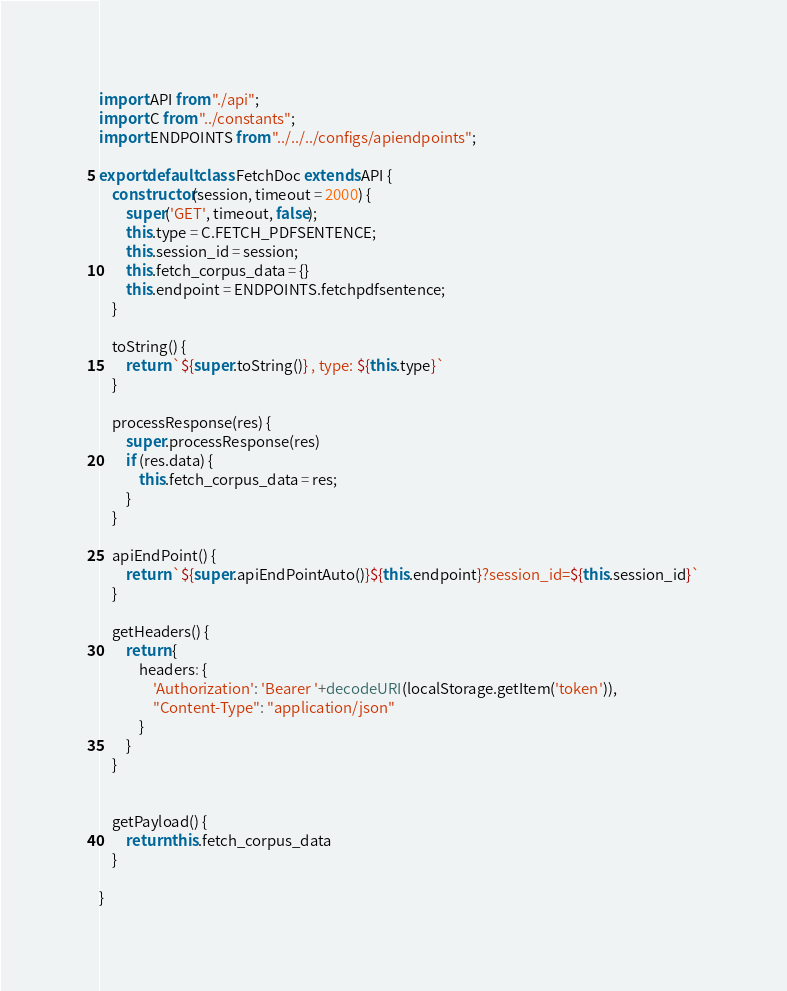<code> <loc_0><loc_0><loc_500><loc_500><_JavaScript_>import API from "./api";
import C from "../constants";
import ENDPOINTS from "../../../configs/apiendpoints";

export default class FetchDoc extends API {
    constructor(session, timeout = 2000) {
        super('GET', timeout, false);
        this.type = C.FETCH_PDFSENTENCE;
        this.session_id = session;
        this.fetch_corpus_data = {}
        this.endpoint = ENDPOINTS.fetchpdfsentence;
    }

    toString() {
        return `${super.toString()} , type: ${this.type}`
    }

    processResponse(res) {
        super.processResponse(res)
        if (res.data) {
            this.fetch_corpus_data = res;
        }
    }

    apiEndPoint() {
        return `${super.apiEndPointAuto()}${this.endpoint}?session_id=${this.session_id}`
    }

    getHeaders() {
        return {
            headers: {
                'Authorization': 'Bearer '+decodeURI(localStorage.getItem('token')), 
                "Content-Type": "application/json"
            }
        }
    }


    getPayload() {
        return this.fetch_corpus_data
    }

}
</code> 